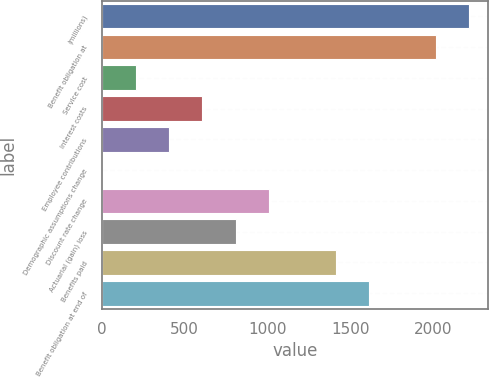<chart> <loc_0><loc_0><loc_500><loc_500><bar_chart><fcel>(millions)<fcel>Benefit obligation at<fcel>Service cost<fcel>Interest costs<fcel>Employee contributions<fcel>Demographic assumptions change<fcel>Discount rate change<fcel>Actuarial (gain) loss<fcel>Benefits paid<fcel>Benefit obligation at end of<nl><fcel>2218.46<fcel>2017<fcel>203.86<fcel>606.78<fcel>405.32<fcel>2.4<fcel>1009.7<fcel>808.24<fcel>1412.62<fcel>1614.08<nl></chart> 